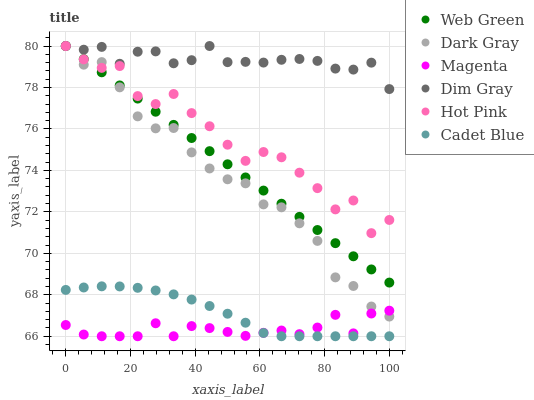Does Magenta have the minimum area under the curve?
Answer yes or no. Yes. Does Dim Gray have the maximum area under the curve?
Answer yes or no. Yes. Does Hot Pink have the minimum area under the curve?
Answer yes or no. No. Does Hot Pink have the maximum area under the curve?
Answer yes or no. No. Is Web Green the smoothest?
Answer yes or no. Yes. Is Hot Pink the roughest?
Answer yes or no. Yes. Is Hot Pink the smoothest?
Answer yes or no. No. Is Web Green the roughest?
Answer yes or no. No. Does Cadet Blue have the lowest value?
Answer yes or no. Yes. Does Hot Pink have the lowest value?
Answer yes or no. No. Does Dark Gray have the highest value?
Answer yes or no. Yes. Does Cadet Blue have the highest value?
Answer yes or no. No. Is Cadet Blue less than Dim Gray?
Answer yes or no. Yes. Is Hot Pink greater than Cadet Blue?
Answer yes or no. Yes. Does Web Green intersect Dim Gray?
Answer yes or no. Yes. Is Web Green less than Dim Gray?
Answer yes or no. No. Is Web Green greater than Dim Gray?
Answer yes or no. No. Does Cadet Blue intersect Dim Gray?
Answer yes or no. No. 